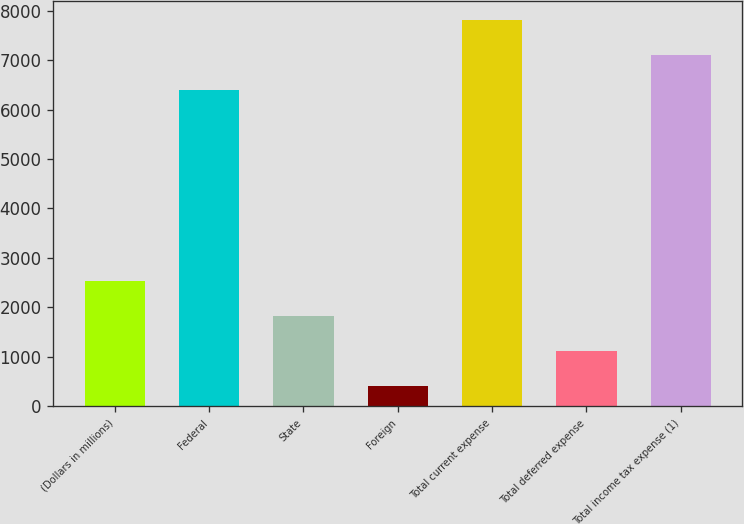<chart> <loc_0><loc_0><loc_500><loc_500><bar_chart><fcel>(Dollars in millions)<fcel>Federal<fcel>State<fcel>Foreign<fcel>Total current expense<fcel>Total deferred expense<fcel>Total income tax expense (1)<nl><fcel>2527.5<fcel>6392<fcel>1820<fcel>405<fcel>7807<fcel>1112.5<fcel>7099.5<nl></chart> 